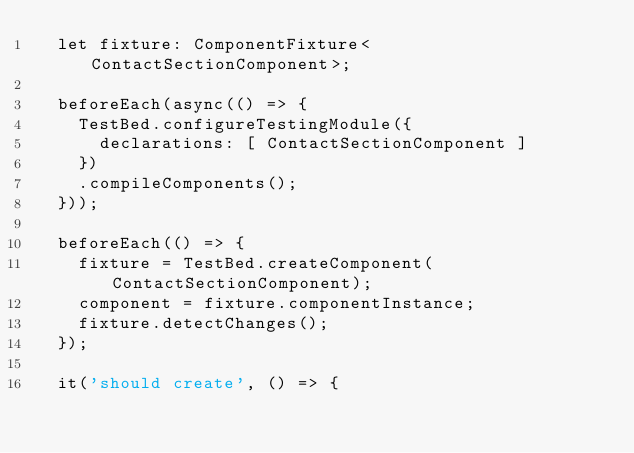<code> <loc_0><loc_0><loc_500><loc_500><_TypeScript_>  let fixture: ComponentFixture<ContactSectionComponent>;

  beforeEach(async(() => {
    TestBed.configureTestingModule({
      declarations: [ ContactSectionComponent ]
    })
    .compileComponents();
  }));

  beforeEach(() => {
    fixture = TestBed.createComponent(ContactSectionComponent);
    component = fixture.componentInstance;
    fixture.detectChanges();
  });

  it('should create', () => {</code> 